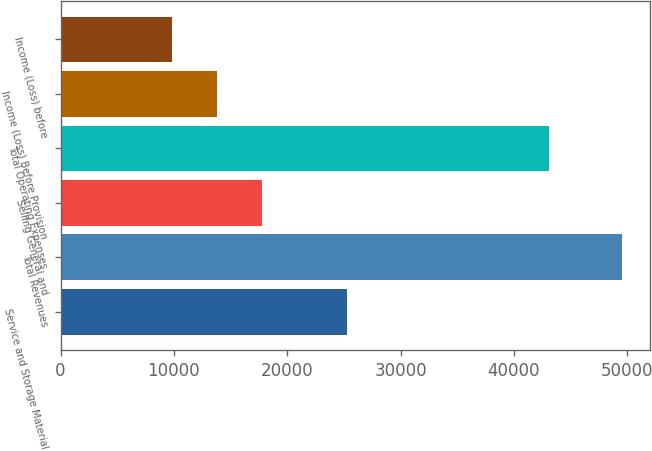Convert chart. <chart><loc_0><loc_0><loc_500><loc_500><bar_chart><fcel>Service and Storage Material<fcel>Total Revenues<fcel>Selling General and<fcel>Total Operating Expenses<fcel>Income (Loss) Before Provision<fcel>Income (Loss) before<nl><fcel>25240<fcel>49578<fcel>17790.8<fcel>43116<fcel>13817.4<fcel>9844<nl></chart> 